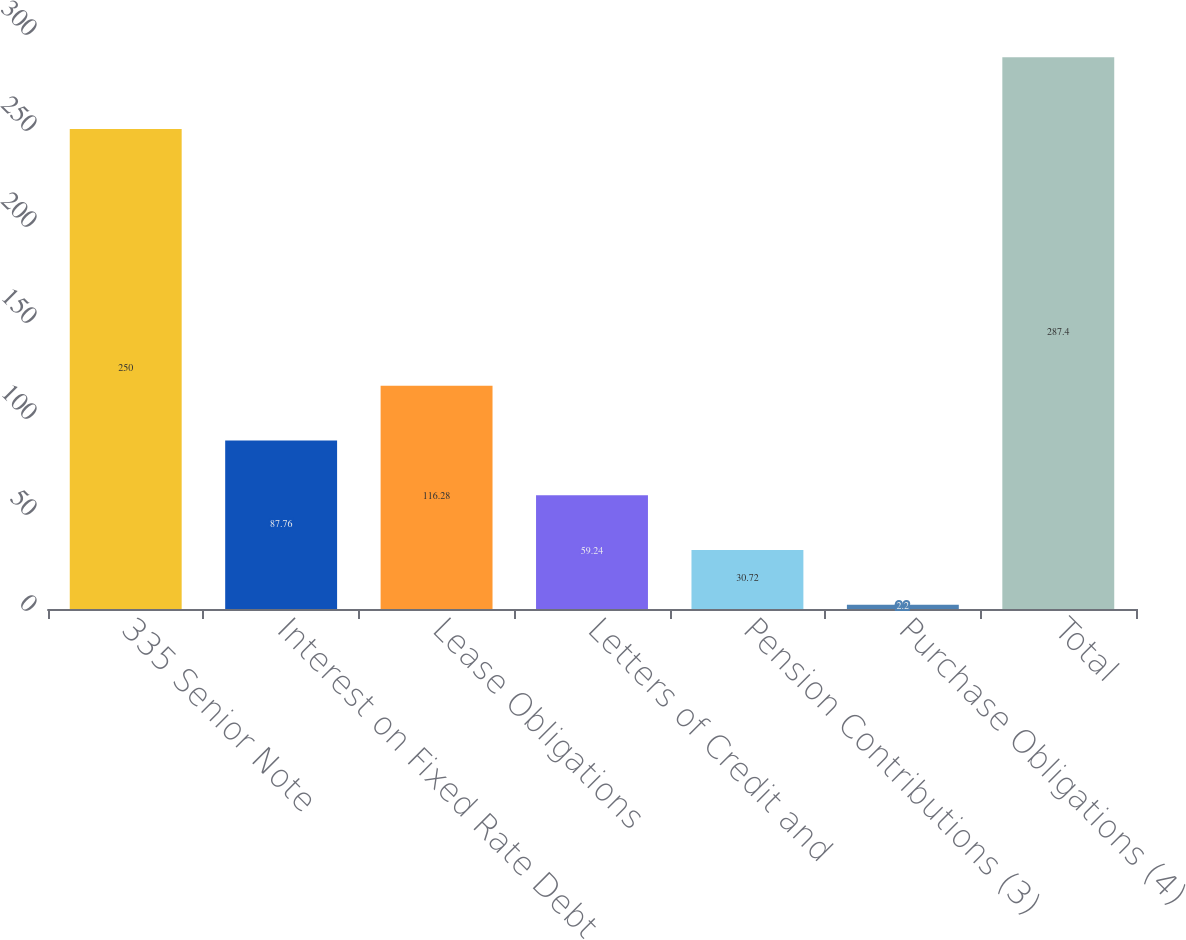Convert chart. <chart><loc_0><loc_0><loc_500><loc_500><bar_chart><fcel>335 Senior Note<fcel>Interest on Fixed Rate Debt<fcel>Lease Obligations<fcel>Letters of Credit and<fcel>Pension Contributions (3)<fcel>Purchase Obligations (4)<fcel>Total<nl><fcel>250<fcel>87.76<fcel>116.28<fcel>59.24<fcel>30.72<fcel>2.2<fcel>287.4<nl></chart> 